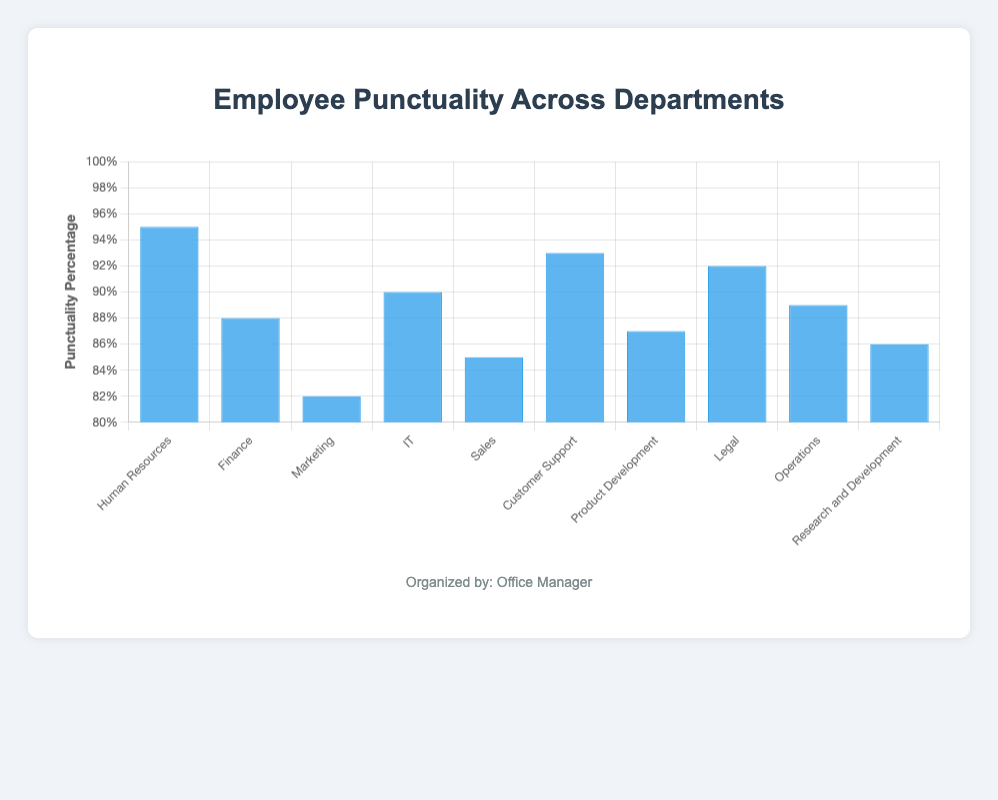What is the punctuality percentage of the Finance department? The Finance department's punctuality percentage is denoted by the height of the corresponding blue bar in the chart.
Answer: 88% Which department has the highest punctuality percentage? The highest bar in the chart corresponds to the department with the highest punctuality percentage. This bar is labeled "Human Resources".
Answer: Human Resources Compare the punctuality percentages of the IT and Customer Support departments. Which one is higher? By observing the height of the bars for IT and Customer Support, it's evident that the bar for Customer Support is higher.
Answer: Customer Support What is the average punctuality percentage across all departments? Sum the punctuality percentages of all departments and divide by the number of departments: (95 + 88 + 82 + 90 + 85 + 93 + 87 + 92 + 89 + 86) / 10 = 887 / 10 = 88.7%
Answer: 88.7% Which departments have a punctuality percentage lower than 90%? Identify the bars with heights corresponding to values below 90. These departments are Finance, Marketing, Sales, Product Development, and Research and Development.
Answer: Finance, Marketing, Sales, Product Development, Research and Development What is the difference in punctuality percentage between the department with the highest and lowest values? Subtract the lowest punctuality percentage from the highest: 95 (Human Resources) - 82 (Marketing) = 13%.
Answer: 13% Which department's punctuality is closest to the average punctuality of all departments? The average punctuality is 88.7%. The departments with punctuality percentages closest to this value are Finance (88) and Operations (89). Comparing the absolute differences, Finance is 0.7 away and Operations is 0.3 away. Therefore, Operations is closer.
Answer: Operations 